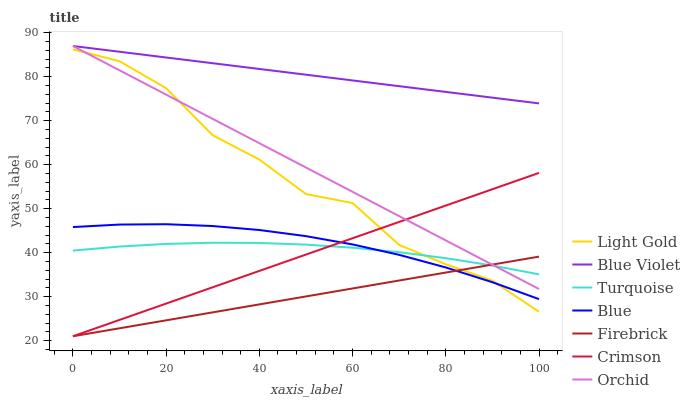Does Firebrick have the minimum area under the curve?
Answer yes or no. Yes. Does Blue Violet have the maximum area under the curve?
Answer yes or no. Yes. Does Turquoise have the minimum area under the curve?
Answer yes or no. No. Does Turquoise have the maximum area under the curve?
Answer yes or no. No. Is Firebrick the smoothest?
Answer yes or no. Yes. Is Light Gold the roughest?
Answer yes or no. Yes. Is Turquoise the smoothest?
Answer yes or no. No. Is Turquoise the roughest?
Answer yes or no. No. Does Turquoise have the lowest value?
Answer yes or no. No. Does Orchid have the highest value?
Answer yes or no. Yes. Does Turquoise have the highest value?
Answer yes or no. No. Is Light Gold less than Blue Violet?
Answer yes or no. Yes. Is Blue Violet greater than Crimson?
Answer yes or no. Yes. Does Blue intersect Turquoise?
Answer yes or no. Yes. Is Blue less than Turquoise?
Answer yes or no. No. Is Blue greater than Turquoise?
Answer yes or no. No. Does Light Gold intersect Blue Violet?
Answer yes or no. No. 